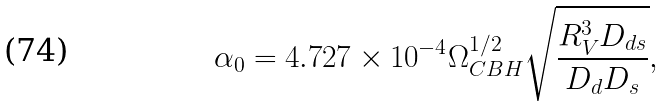Convert formula to latex. <formula><loc_0><loc_0><loc_500><loc_500>\alpha _ { 0 } = 4 . 7 2 7 \times 1 0 ^ { - 4 } \Omega _ { C B H } ^ { 1 / 2 } \sqrt { \frac { R _ { V } ^ { 3 } D _ { d s } } { D _ { d } D _ { s } } } ,</formula> 